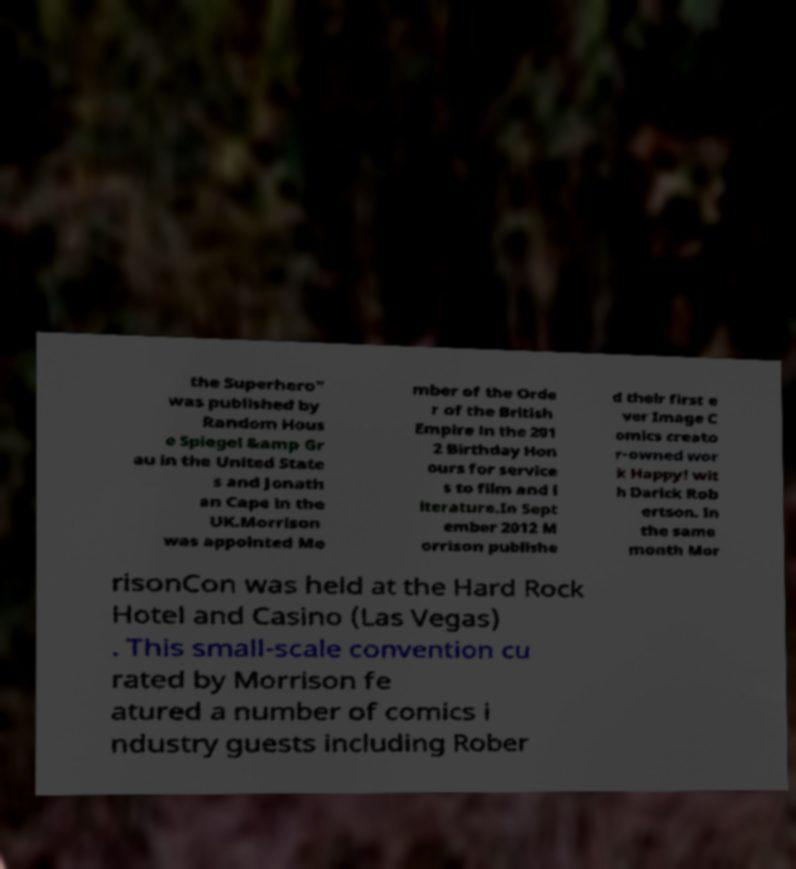I need the written content from this picture converted into text. Can you do that? the Superhero" was published by Random Hous e Spiegel &amp Gr au in the United State s and Jonath an Cape in the UK.Morrison was appointed Me mber of the Orde r of the British Empire in the 201 2 Birthday Hon ours for service s to film and l iterature.In Sept ember 2012 M orrison publishe d their first e ver Image C omics creato r-owned wor k Happy! wit h Darick Rob ertson. In the same month Mor risonCon was held at the Hard Rock Hotel and Casino (Las Vegas) . This small-scale convention cu rated by Morrison fe atured a number of comics i ndustry guests including Rober 